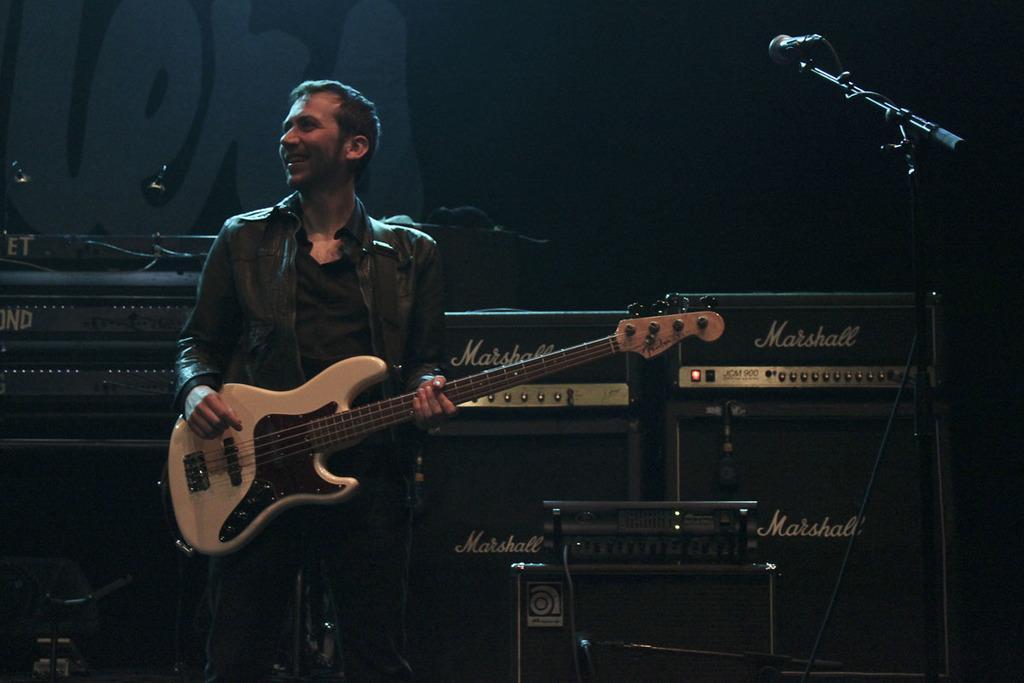Please provide a concise description of this image. This picture shows a man standing and playing a guitar and we see a smile on his face and a microphone on the side. 